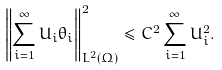Convert formula to latex. <formula><loc_0><loc_0><loc_500><loc_500>\left \| \sum _ { i = 1 } ^ { \infty } U _ { i } \theta _ { i } \right \| ^ { 2 } _ { L ^ { 2 } ( \Omega ) } \leq C ^ { 2 } \sum _ { i = 1 } ^ { \infty } U _ { i } ^ { 2 } .</formula> 